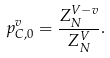Convert formula to latex. <formula><loc_0><loc_0><loc_500><loc_500>p ^ { v } _ { C , 0 } = \frac { Z _ { N } ^ { V - v } } { Z _ { N } ^ { V } } .</formula> 